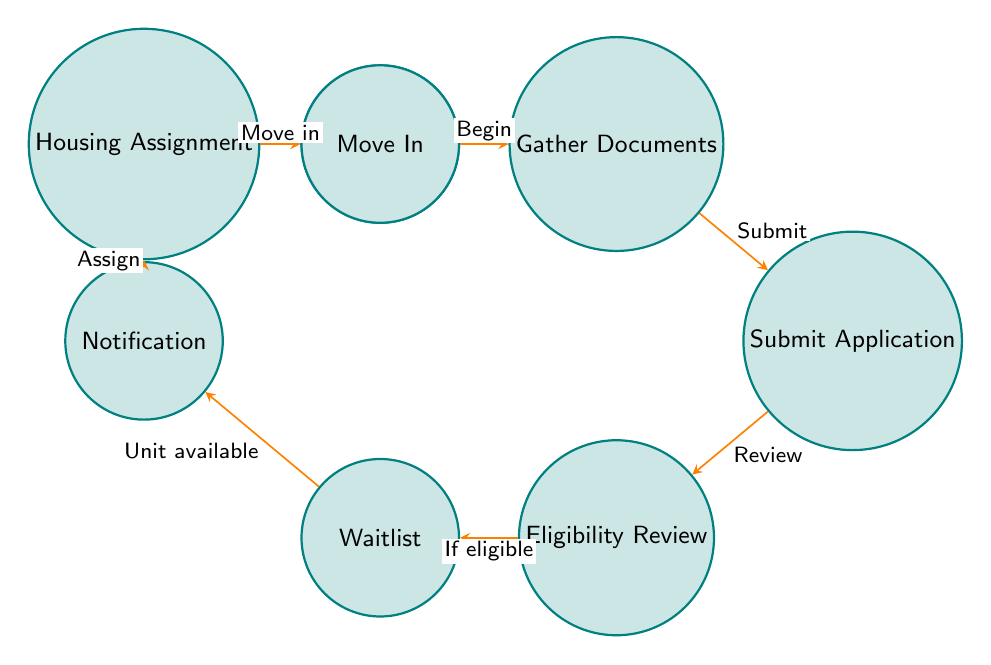What is the first action an applicant must take? The diagram starts at the 'Start' node, which indicates that the first action is to move to the 'Gather Documents' state.
Answer: Gather Documents How many states does the process have? By counting the states in the diagram, we identify eight distinct states from 'Start' to 'Move In'.
Answer: Eight What is the last state of the process? The last state is 'Move In', as indicated in the flow of the diagram, showing the final step after being assigned housing.
Answer: Move In What happens after an application is submitted? After 'Submit Application', the next transition leads to 'Eligibility Review', where the application is reviewed for eligibility by the housing authority.
Answer: Eligibility Review What condition leads to being on the waitlist? The process moves to the 'Waitlist' state if the application is verified as 'eligible' during the 'Eligibility Review'.
Answer: Eligible What comes after being notified of housing availability? After 'Notification', the next step for the applicant is to enter 'Housing Assignment', where they are assigned a housing unit.
Answer: Housing Assignment How many transitions are there from 'Eligibility Review'? From 'Eligibility Review', there is only one transition to the 'Waitlist' state, indicating the next step if eligible.
Answer: One What must an applicant do to start the application process? To begin, the applicant needs to gather all necessary documents as the first step from the 'Start' node.
Answer: Gather Documents 